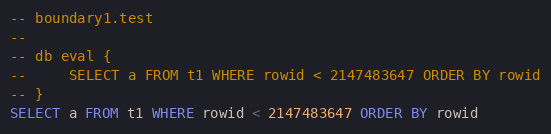<code> <loc_0><loc_0><loc_500><loc_500><_SQL_>-- boundary1.test
-- 
-- db eval {
--     SELECT a FROM t1 WHERE rowid < 2147483647 ORDER BY rowid
-- }
SELECT a FROM t1 WHERE rowid < 2147483647 ORDER BY rowid</code> 